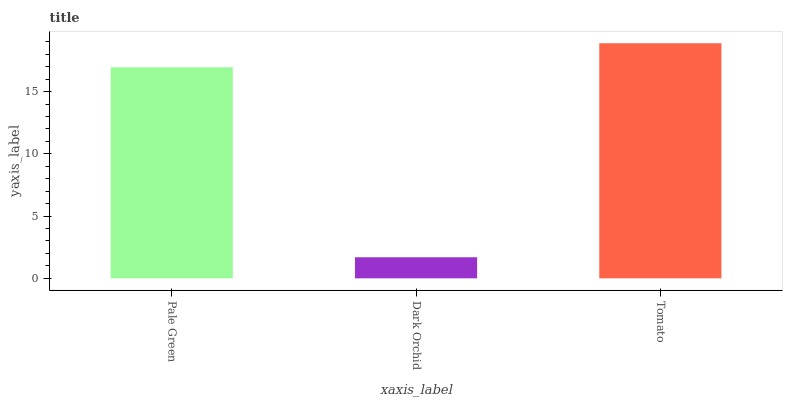Is Tomato the minimum?
Answer yes or no. No. Is Dark Orchid the maximum?
Answer yes or no. No. Is Tomato greater than Dark Orchid?
Answer yes or no. Yes. Is Dark Orchid less than Tomato?
Answer yes or no. Yes. Is Dark Orchid greater than Tomato?
Answer yes or no. No. Is Tomato less than Dark Orchid?
Answer yes or no. No. Is Pale Green the high median?
Answer yes or no. Yes. Is Pale Green the low median?
Answer yes or no. Yes. Is Dark Orchid the high median?
Answer yes or no. No. Is Dark Orchid the low median?
Answer yes or no. No. 